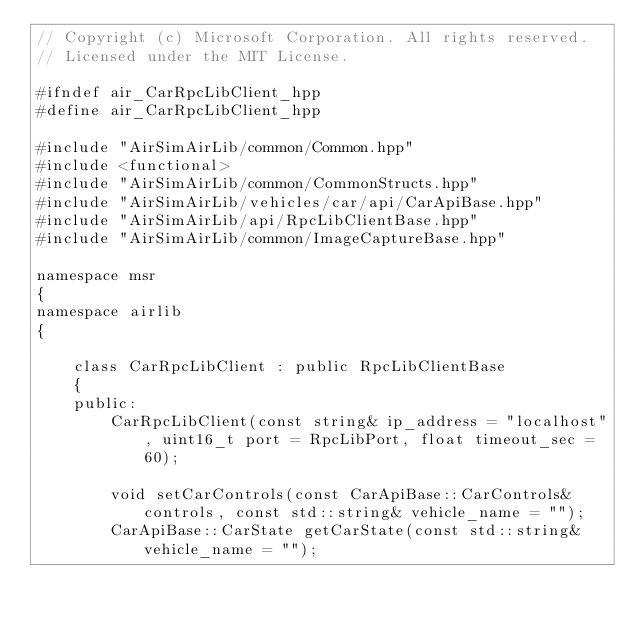Convert code to text. <code><loc_0><loc_0><loc_500><loc_500><_C++_>// Copyright (c) Microsoft Corporation. All rights reserved.
// Licensed under the MIT License.

#ifndef air_CarRpcLibClient_hpp
#define air_CarRpcLibClient_hpp

#include "AirSimAirLib/common/Common.hpp"
#include <functional>
#include "AirSimAirLib/common/CommonStructs.hpp"
#include "AirSimAirLib/vehicles/car/api/CarApiBase.hpp"
#include "AirSimAirLib/api/RpcLibClientBase.hpp"
#include "AirSimAirLib/common/ImageCaptureBase.hpp"

namespace msr
{
namespace airlib
{

    class CarRpcLibClient : public RpcLibClientBase
    {
    public:
        CarRpcLibClient(const string& ip_address = "localhost", uint16_t port = RpcLibPort, float timeout_sec = 60);

        void setCarControls(const CarApiBase::CarControls& controls, const std::string& vehicle_name = "");
        CarApiBase::CarState getCarState(const std::string& vehicle_name = "");</code> 